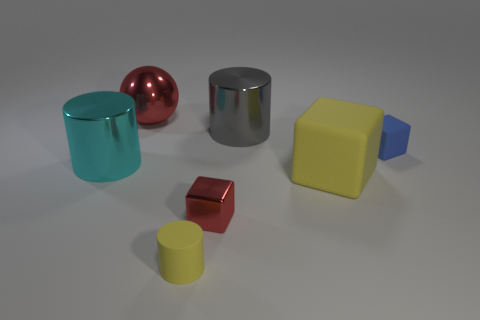There is a metal cylinder to the right of the small yellow matte thing that is left of the cylinder that is on the right side of the small cylinder; how big is it?
Your answer should be very brief. Large. Is the number of small blue cubes greater than the number of small purple rubber objects?
Make the answer very short. Yes. There is a rubber block on the right side of the yellow cube; is it the same color as the cylinder that is in front of the small metallic cube?
Make the answer very short. No. Is the large cylinder to the right of the rubber cylinder made of the same material as the tiny object to the left of the small red thing?
Provide a succinct answer. No. How many cylinders are the same size as the yellow block?
Give a very brief answer. 2. Are there fewer shiny balls than purple metal blocks?
Offer a terse response. No. The small rubber thing right of the rubber object in front of the tiny metal object is what shape?
Provide a succinct answer. Cube. There is a rubber object that is the same size as the gray cylinder; what is its shape?
Your response must be concise. Cube. Is there a large gray object of the same shape as the blue rubber thing?
Ensure brevity in your answer.  No. What material is the big ball?
Provide a short and direct response. Metal. 